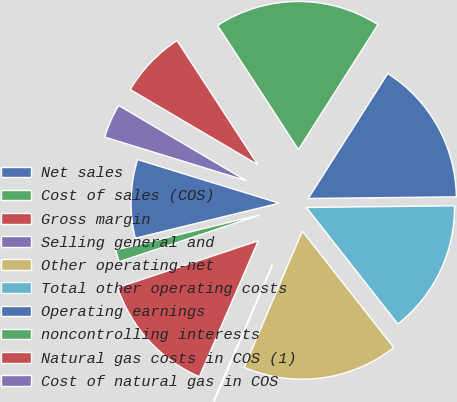<chart> <loc_0><loc_0><loc_500><loc_500><pie_chart><fcel>Net sales<fcel>Cost of sales (COS)<fcel>Gross margin<fcel>Selling general and<fcel>Other operating-net<fcel>Total other operating costs<fcel>Operating earnings<fcel>noncontrolling interests<fcel>Natural gas costs in COS (1)<fcel>Cost of natural gas in COS<nl><fcel>8.55%<fcel>1.31%<fcel>13.38%<fcel>0.1%<fcel>17.0%<fcel>14.59%<fcel>15.8%<fcel>18.21%<fcel>7.34%<fcel>3.72%<nl></chart> 